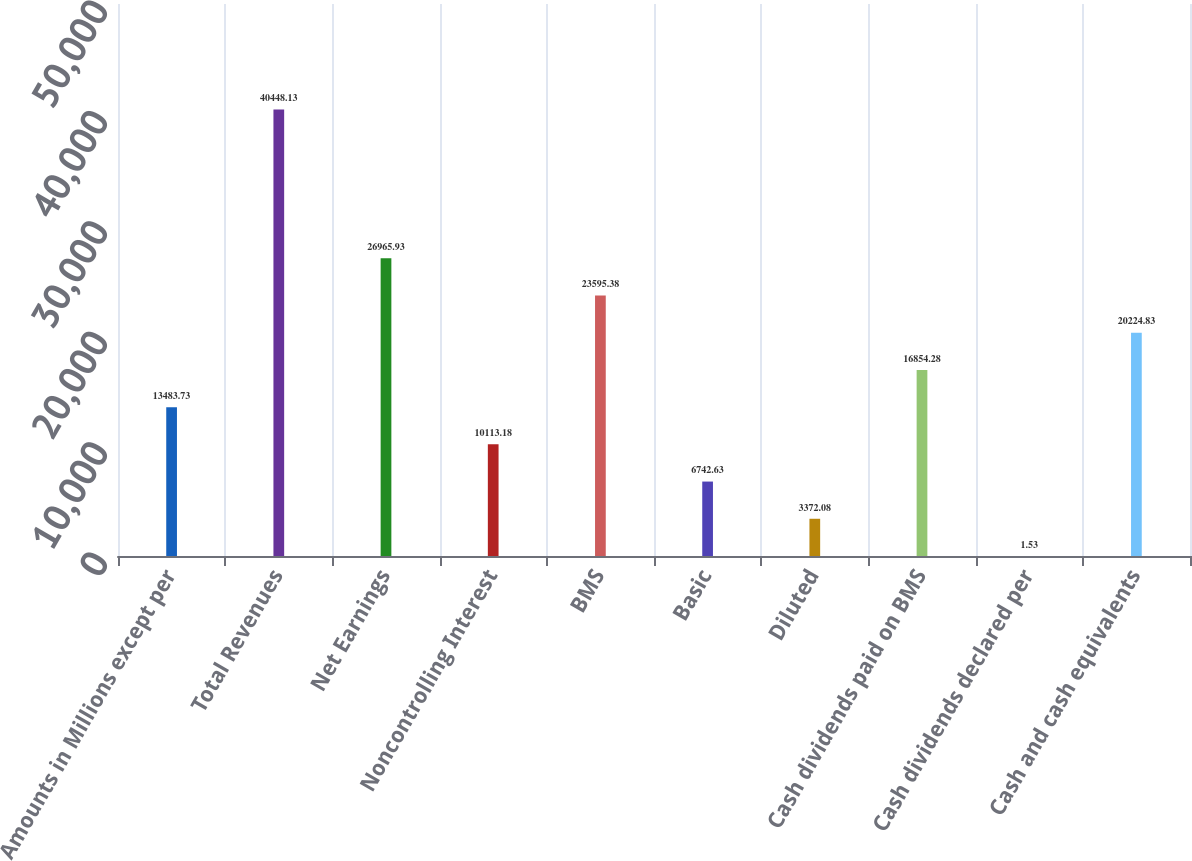Convert chart to OTSL. <chart><loc_0><loc_0><loc_500><loc_500><bar_chart><fcel>Amounts in Millions except per<fcel>Total Revenues<fcel>Net Earnings<fcel>Noncontrolling Interest<fcel>BMS<fcel>Basic<fcel>Diluted<fcel>Cash dividends paid on BMS<fcel>Cash dividends declared per<fcel>Cash and cash equivalents<nl><fcel>13483.7<fcel>40448.1<fcel>26965.9<fcel>10113.2<fcel>23595.4<fcel>6742.63<fcel>3372.08<fcel>16854.3<fcel>1.53<fcel>20224.8<nl></chart> 